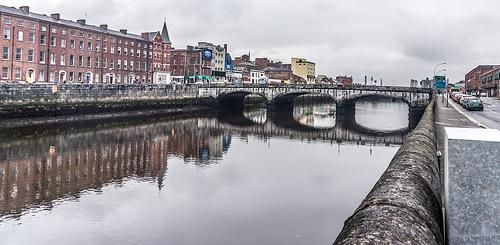Question: how is the water?
Choices:
A. Cold.
B. Warm.
C. Rough.
D. Calm.
Answer with the letter. Answer: D Question: what is the sky like?
Choices:
A. Clear.
B. Overcast.
C. Dark.
D. Sunny.
Answer with the letter. Answer: B Question: why is there a bridge?
Choices:
A. To cross railroad tracks.
B. To go from one interstate to another.
C. Across river.
D. To allow cars to pass over a ditch.
Answer with the letter. Answer: C 